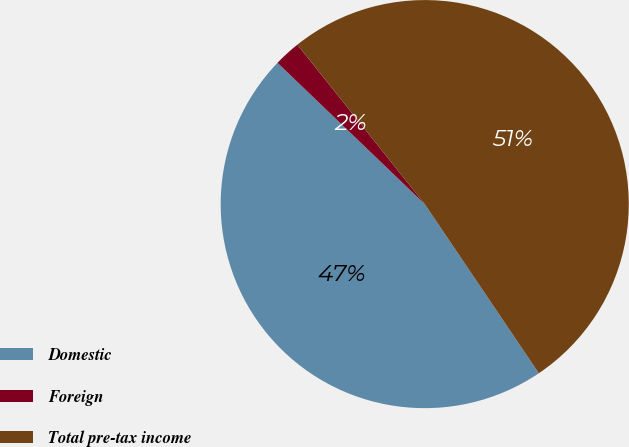<chart> <loc_0><loc_0><loc_500><loc_500><pie_chart><fcel>Domestic<fcel>Foreign<fcel>Total pre-tax income<nl><fcel>46.62%<fcel>2.1%<fcel>51.28%<nl></chart> 